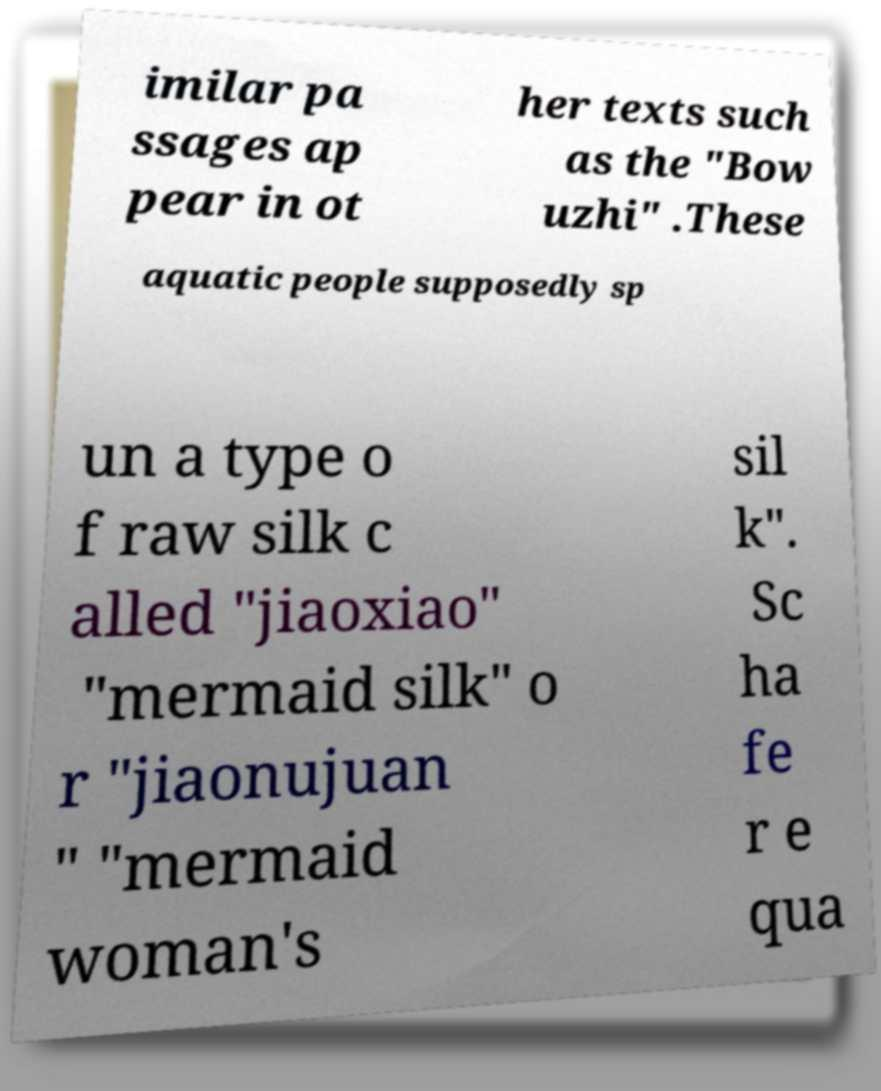For documentation purposes, I need the text within this image transcribed. Could you provide that? imilar pa ssages ap pear in ot her texts such as the "Bow uzhi" .These aquatic people supposedly sp un a type o f raw silk c alled "jiaoxiao" "mermaid silk" o r "jiaonujuan " "mermaid woman's sil k". Sc ha fe r e qua 